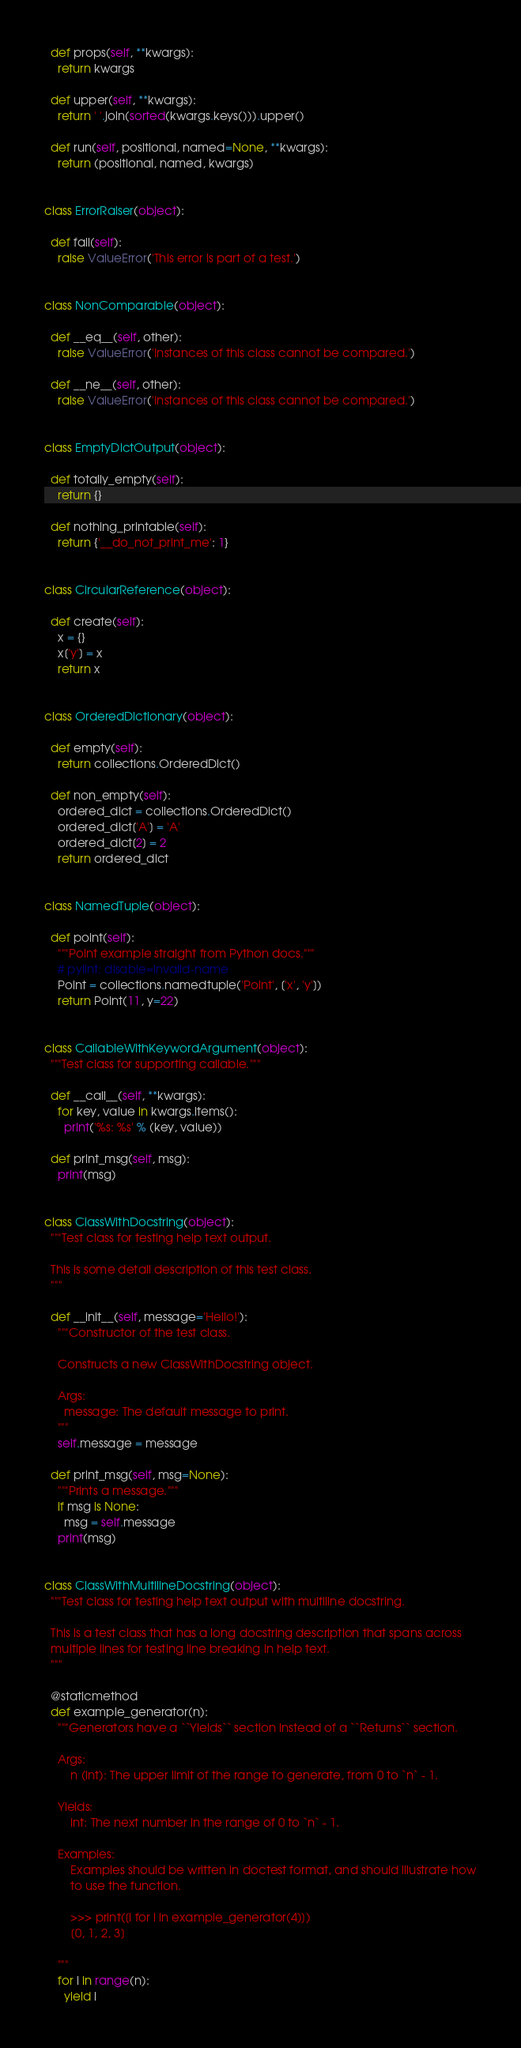Convert code to text. <code><loc_0><loc_0><loc_500><loc_500><_Python_>
  def props(self, **kwargs):
    return kwargs

  def upper(self, **kwargs):
    return ' '.join(sorted(kwargs.keys())).upper()

  def run(self, positional, named=None, **kwargs):
    return (positional, named, kwargs)


class ErrorRaiser(object):

  def fail(self):
    raise ValueError('This error is part of a test.')


class NonComparable(object):

  def __eq__(self, other):
    raise ValueError('Instances of this class cannot be compared.')

  def __ne__(self, other):
    raise ValueError('Instances of this class cannot be compared.')


class EmptyDictOutput(object):

  def totally_empty(self):
    return {}

  def nothing_printable(self):
    return {'__do_not_print_me': 1}


class CircularReference(object):

  def create(self):
    x = {}
    x['y'] = x
    return x


class OrderedDictionary(object):

  def empty(self):
    return collections.OrderedDict()

  def non_empty(self):
    ordered_dict = collections.OrderedDict()
    ordered_dict['A'] = 'A'
    ordered_dict[2] = 2
    return ordered_dict


class NamedTuple(object):

  def point(self):
    """Point example straight from Python docs."""
    # pylint: disable=invalid-name
    Point = collections.namedtuple('Point', ['x', 'y'])
    return Point(11, y=22)


class CallableWithKeywordArgument(object):
  """Test class for supporting callable."""

  def __call__(self, **kwargs):
    for key, value in kwargs.items():
      print('%s: %s' % (key, value))

  def print_msg(self, msg):
    print(msg)


class ClassWithDocstring(object):
  """Test class for testing help text output.

  This is some detail description of this test class.
  """

  def __init__(self, message='Hello!'):
    """Constructor of the test class.

    Constructs a new ClassWithDocstring object.

    Args:
      message: The default message to print.
    """
    self.message = message

  def print_msg(self, msg=None):
    """Prints a message."""
    if msg is None:
      msg = self.message
    print(msg)


class ClassWithMultilineDocstring(object):
  """Test class for testing help text output with multiline docstring.

  This is a test class that has a long docstring description that spans across
  multiple lines for testing line breaking in help text.
  """

  @staticmethod
  def example_generator(n):
    """Generators have a ``Yields`` section instead of a ``Returns`` section.

    Args:
        n (int): The upper limit of the range to generate, from 0 to `n` - 1.

    Yields:
        int: The next number in the range of 0 to `n` - 1.

    Examples:
        Examples should be written in doctest format, and should illustrate how
        to use the function.

        >>> print([i for i in example_generator(4)])
        [0, 1, 2, 3]

    """
    for i in range(n):
      yield i
</code> 